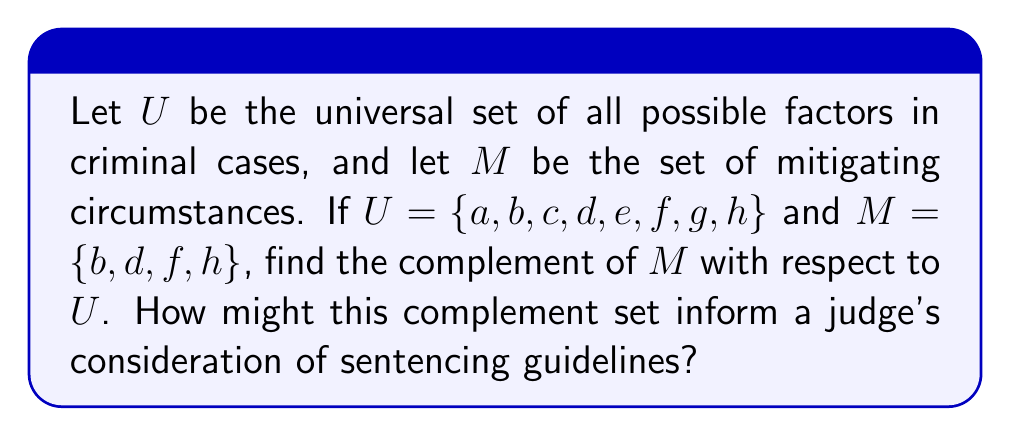What is the answer to this math problem? To solve this problem, we need to understand the concept of set complement and apply it to the given sets. The complement of a set $A$ with respect to the universal set $U$ is denoted as $A^c$ or $\overline{A}$, and it consists of all elements in $U$ that are not in $A$.

Given:
$U = \{a, b, c, d, e, f, g, h\}$ (universal set)
$M = \{b, d, f, h\}$ (set of mitigating circumstances)

To find the complement of $M$, we need to identify all elements in $U$ that are not in $M$:

$M^c = \{a, c, e, g\}$

This set represents all factors that are not mitigating circumstances.

In the context of criminal cases and sentencing guidelines, the complement set $M^c$ could represent aggravating factors or neutral circumstances that a judge might need to consider. By understanding both the mitigating circumstances ($M$) and their complement ($M^c$), a judge can have a more comprehensive view of all factors involved in a case.

The elements in $M^c$ might include:
$a$: Severity of the crime
$c$: Prior criminal record
$e$: Impact on the victim
$g$: Lack of remorse

Understanding these non-mitigating factors alongside the mitigating circumstances can help a judge make a more balanced decision when considering sentencing guidelines.
Answer: $M^c = \{a, c, e, g\}$ 